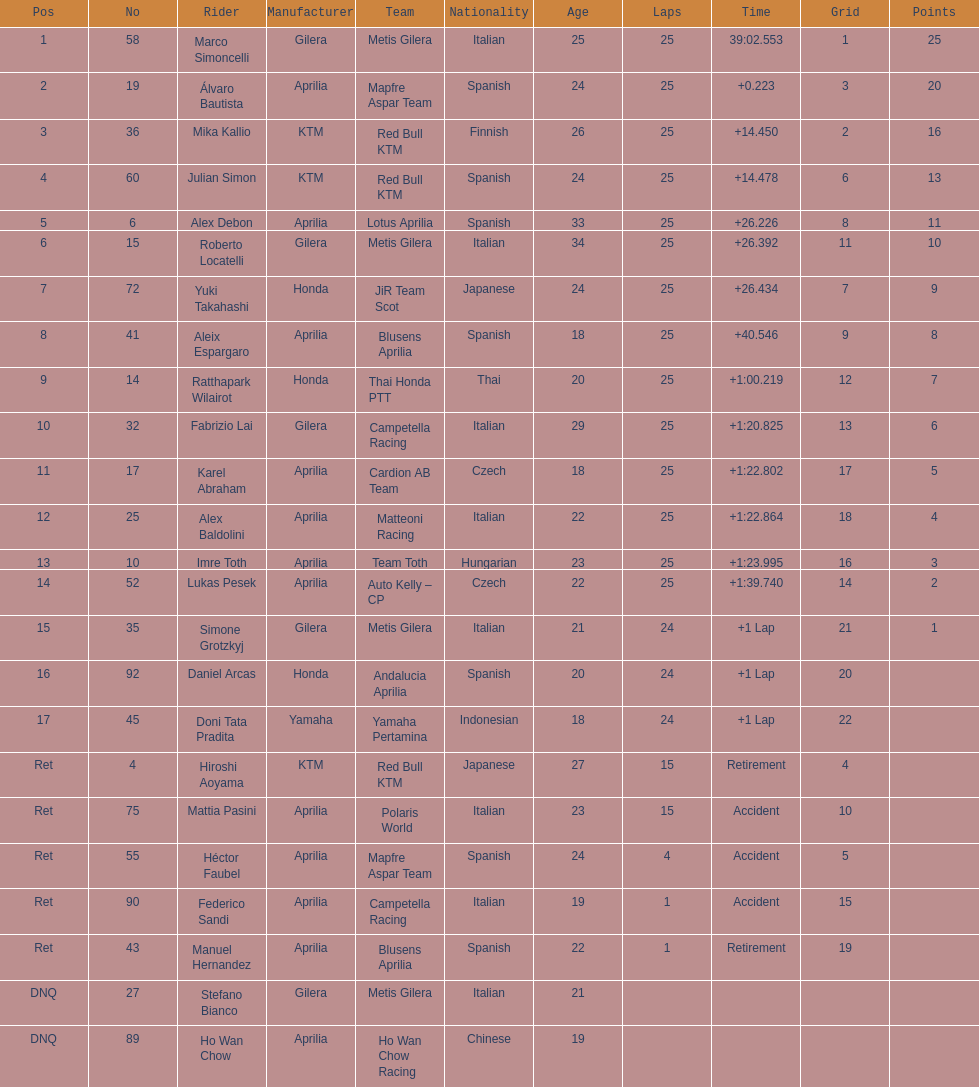Who is marco simoncelli's manufacturer Gilera. 